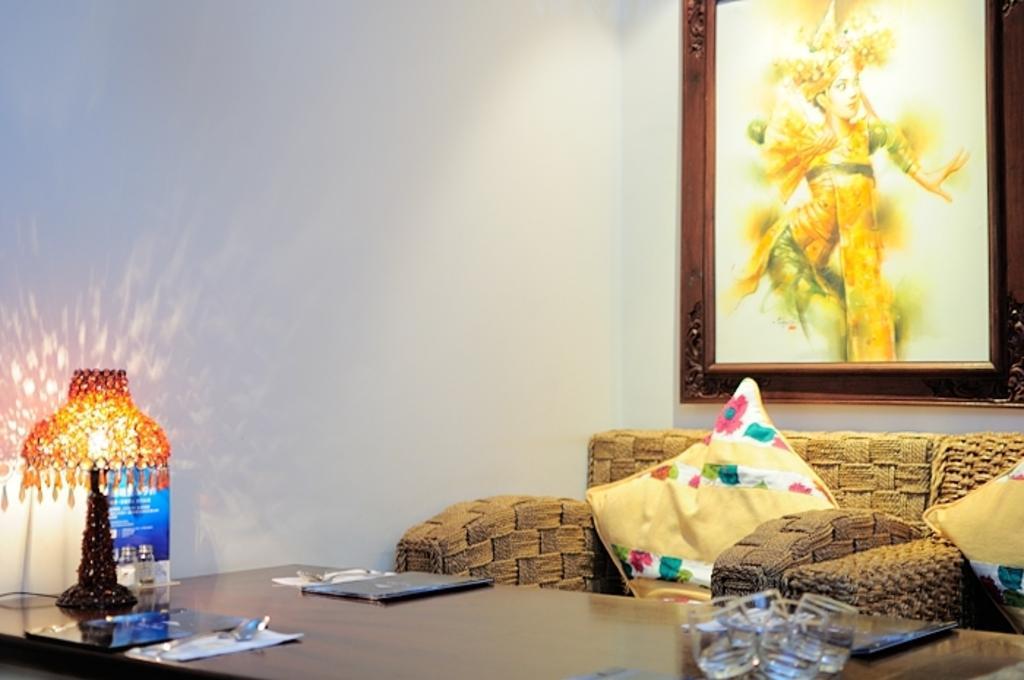Please provide a concise description of this image. In this image on the right side there is one couch and on that couch there are two pillows. Beside the couch there is one photo frame on the wall and on the right side there is one lamp and one table is there. On the table there are some glasses and papers are there on the top there is wall. 